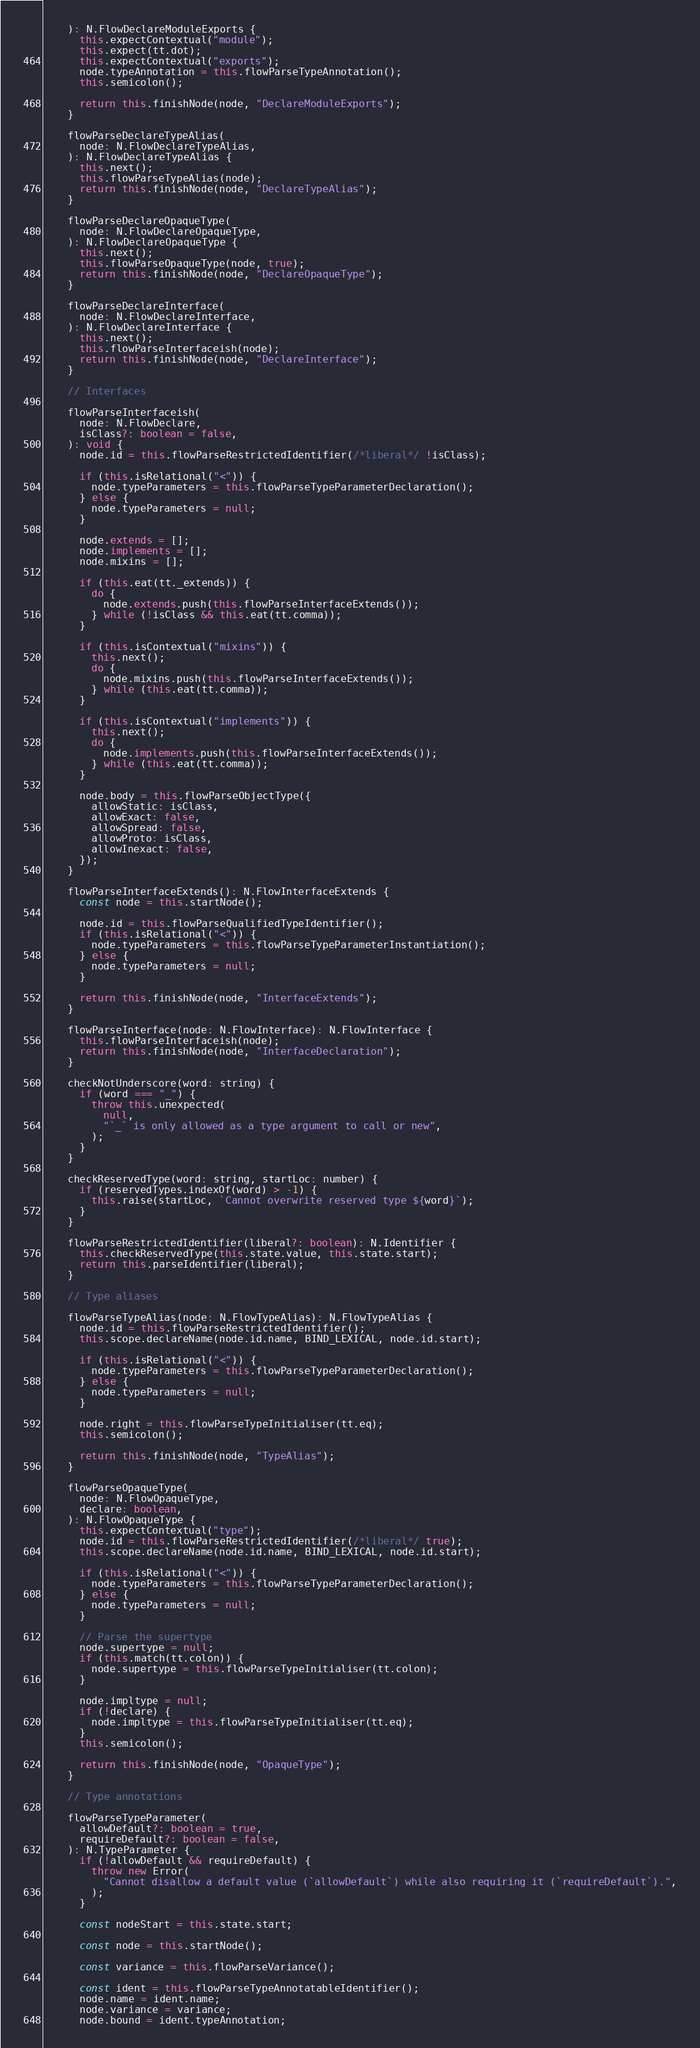Convert code to text. <code><loc_0><loc_0><loc_500><loc_500><_JavaScript_>    ): N.FlowDeclareModuleExports {
      this.expectContextual("module");
      this.expect(tt.dot);
      this.expectContextual("exports");
      node.typeAnnotation = this.flowParseTypeAnnotation();
      this.semicolon();

      return this.finishNode(node, "DeclareModuleExports");
    }

    flowParseDeclareTypeAlias(
      node: N.FlowDeclareTypeAlias,
    ): N.FlowDeclareTypeAlias {
      this.next();
      this.flowParseTypeAlias(node);
      return this.finishNode(node, "DeclareTypeAlias");
    }

    flowParseDeclareOpaqueType(
      node: N.FlowDeclareOpaqueType,
    ): N.FlowDeclareOpaqueType {
      this.next();
      this.flowParseOpaqueType(node, true);
      return this.finishNode(node, "DeclareOpaqueType");
    }

    flowParseDeclareInterface(
      node: N.FlowDeclareInterface,
    ): N.FlowDeclareInterface {
      this.next();
      this.flowParseInterfaceish(node);
      return this.finishNode(node, "DeclareInterface");
    }

    // Interfaces

    flowParseInterfaceish(
      node: N.FlowDeclare,
      isClass?: boolean = false,
    ): void {
      node.id = this.flowParseRestrictedIdentifier(/*liberal*/ !isClass);

      if (this.isRelational("<")) {
        node.typeParameters = this.flowParseTypeParameterDeclaration();
      } else {
        node.typeParameters = null;
      }

      node.extends = [];
      node.implements = [];
      node.mixins = [];

      if (this.eat(tt._extends)) {
        do {
          node.extends.push(this.flowParseInterfaceExtends());
        } while (!isClass && this.eat(tt.comma));
      }

      if (this.isContextual("mixins")) {
        this.next();
        do {
          node.mixins.push(this.flowParseInterfaceExtends());
        } while (this.eat(tt.comma));
      }

      if (this.isContextual("implements")) {
        this.next();
        do {
          node.implements.push(this.flowParseInterfaceExtends());
        } while (this.eat(tt.comma));
      }

      node.body = this.flowParseObjectType({
        allowStatic: isClass,
        allowExact: false,
        allowSpread: false,
        allowProto: isClass,
        allowInexact: false,
      });
    }

    flowParseInterfaceExtends(): N.FlowInterfaceExtends {
      const node = this.startNode();

      node.id = this.flowParseQualifiedTypeIdentifier();
      if (this.isRelational("<")) {
        node.typeParameters = this.flowParseTypeParameterInstantiation();
      } else {
        node.typeParameters = null;
      }

      return this.finishNode(node, "InterfaceExtends");
    }

    flowParseInterface(node: N.FlowInterface): N.FlowInterface {
      this.flowParseInterfaceish(node);
      return this.finishNode(node, "InterfaceDeclaration");
    }

    checkNotUnderscore(word: string) {
      if (word === "_") {
        throw this.unexpected(
          null,
          "`_` is only allowed as a type argument to call or new",
        );
      }
    }

    checkReservedType(word: string, startLoc: number) {
      if (reservedTypes.indexOf(word) > -1) {
        this.raise(startLoc, `Cannot overwrite reserved type ${word}`);
      }
    }

    flowParseRestrictedIdentifier(liberal?: boolean): N.Identifier {
      this.checkReservedType(this.state.value, this.state.start);
      return this.parseIdentifier(liberal);
    }

    // Type aliases

    flowParseTypeAlias(node: N.FlowTypeAlias): N.FlowTypeAlias {
      node.id = this.flowParseRestrictedIdentifier();
      this.scope.declareName(node.id.name, BIND_LEXICAL, node.id.start);

      if (this.isRelational("<")) {
        node.typeParameters = this.flowParseTypeParameterDeclaration();
      } else {
        node.typeParameters = null;
      }

      node.right = this.flowParseTypeInitialiser(tt.eq);
      this.semicolon();

      return this.finishNode(node, "TypeAlias");
    }

    flowParseOpaqueType(
      node: N.FlowOpaqueType,
      declare: boolean,
    ): N.FlowOpaqueType {
      this.expectContextual("type");
      node.id = this.flowParseRestrictedIdentifier(/*liberal*/ true);
      this.scope.declareName(node.id.name, BIND_LEXICAL, node.id.start);

      if (this.isRelational("<")) {
        node.typeParameters = this.flowParseTypeParameterDeclaration();
      } else {
        node.typeParameters = null;
      }

      // Parse the supertype
      node.supertype = null;
      if (this.match(tt.colon)) {
        node.supertype = this.flowParseTypeInitialiser(tt.colon);
      }

      node.impltype = null;
      if (!declare) {
        node.impltype = this.flowParseTypeInitialiser(tt.eq);
      }
      this.semicolon();

      return this.finishNode(node, "OpaqueType");
    }

    // Type annotations

    flowParseTypeParameter(
      allowDefault?: boolean = true,
      requireDefault?: boolean = false,
    ): N.TypeParameter {
      if (!allowDefault && requireDefault) {
        throw new Error(
          "Cannot disallow a default value (`allowDefault`) while also requiring it (`requireDefault`).",
        );
      }

      const nodeStart = this.state.start;

      const node = this.startNode();

      const variance = this.flowParseVariance();

      const ident = this.flowParseTypeAnnotatableIdentifier();
      node.name = ident.name;
      node.variance = variance;
      node.bound = ident.typeAnnotation;
</code> 